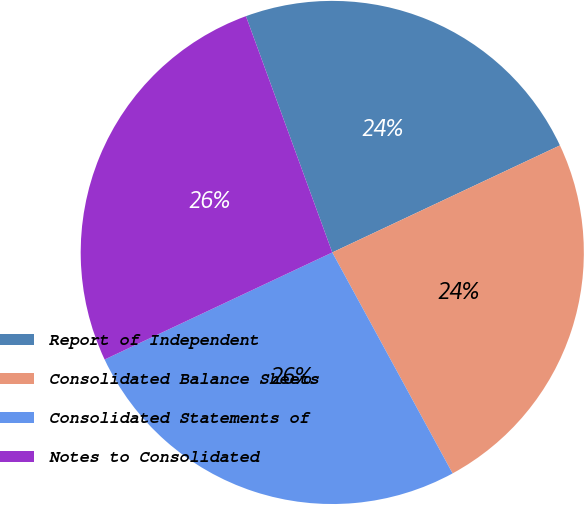Convert chart to OTSL. <chart><loc_0><loc_0><loc_500><loc_500><pie_chart><fcel>Report of Independent<fcel>Consolidated Balance Sheets<fcel>Consolidated Statements of<fcel>Notes to Consolidated<nl><fcel>23.58%<fcel>24.06%<fcel>25.94%<fcel>26.42%<nl></chart> 